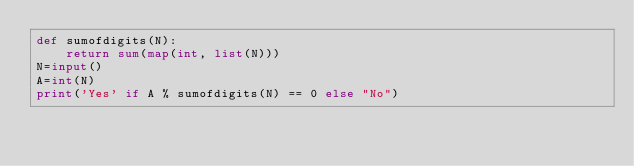Convert code to text. <code><loc_0><loc_0><loc_500><loc_500><_Python_>def sumofdigits(N):
    return sum(map(int, list(N)))
N=input()
A=int(N)
print('Yes' if A % sumofdigits(N) == 0 else "No")
</code> 